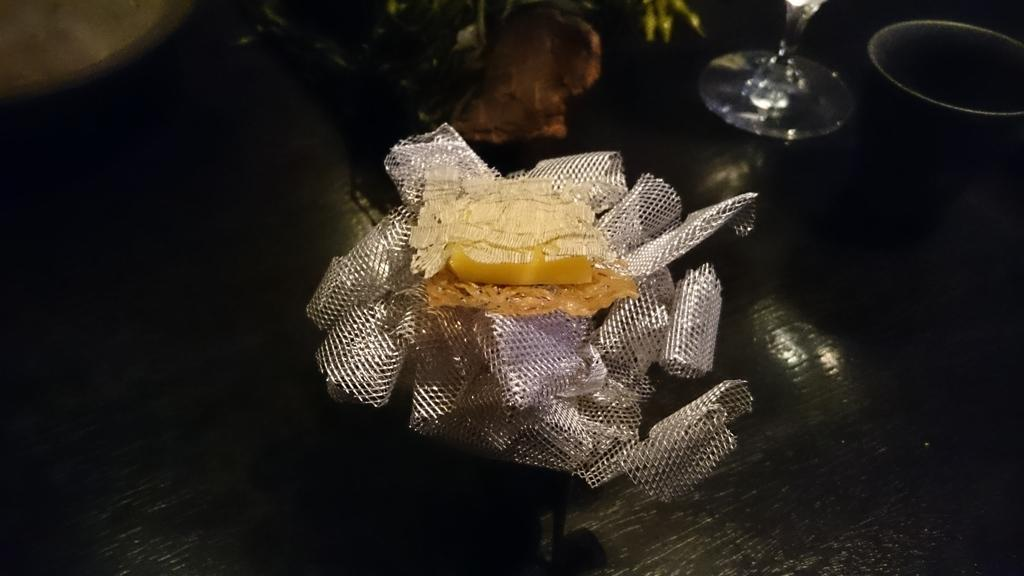What is the color of the paper wrapped around the item in the image? The paper is wrapped in golden color in the image. What is the color of the object that the item is placed on? The object is silver in the image. Where is the silver object located? The silver object is on a platform in the image. What type of container can be seen in the image? There is a glass in the image. What is another flat object present in the image? There is a plate in the image. Can you describe any other objects visible in the image? There are other objects in the image, but their specific details are not mentioned in the provided facts. How does the bat contribute to the growth of the item wrapped in golden color paper? There is no bat present in the image, so it cannot contribute to the growth of the item. 